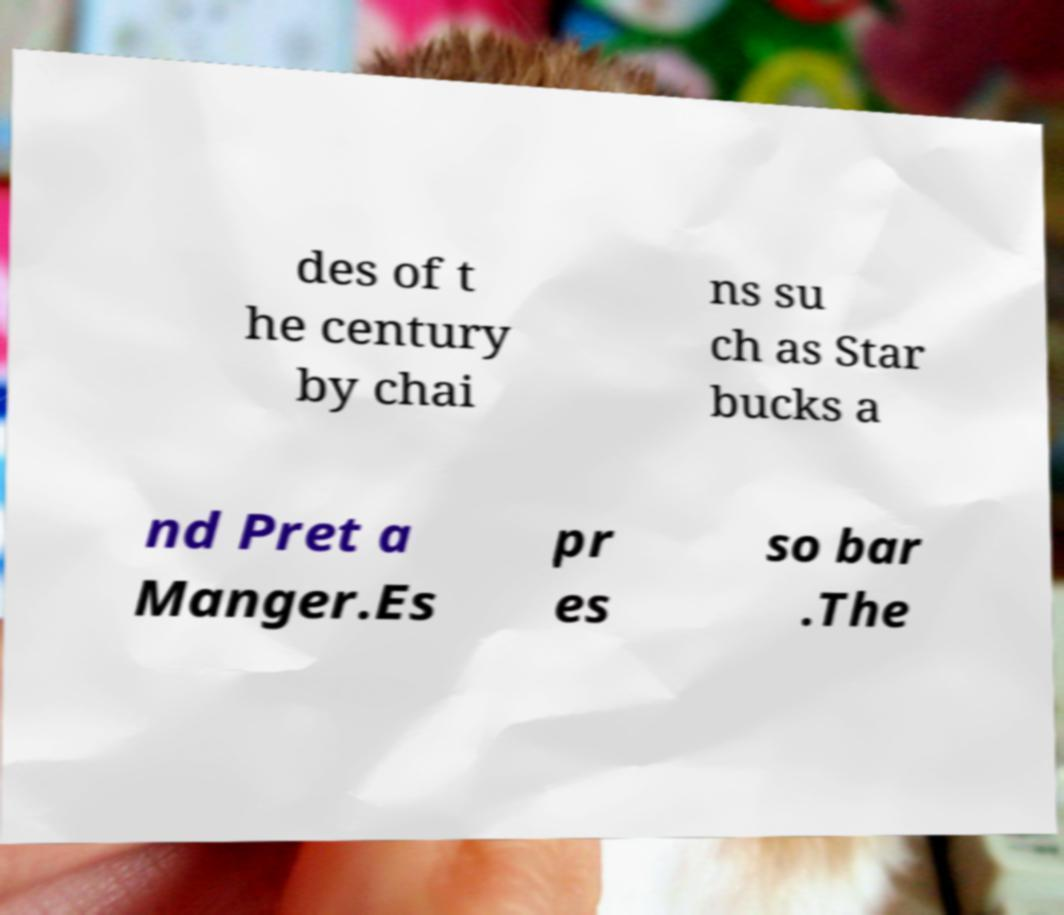For documentation purposes, I need the text within this image transcribed. Could you provide that? des of t he century by chai ns su ch as Star bucks a nd Pret a Manger.Es pr es so bar .The 